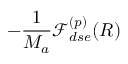Convert formula to latex. <formula><loc_0><loc_0><loc_500><loc_500>- \frac { 1 } { M _ { a } } \mathcal { F } _ { d s e } ^ { ( p ) } ( R )</formula> 